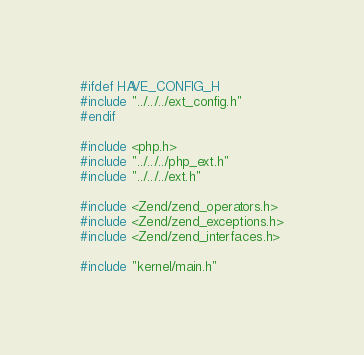Convert code to text. <code><loc_0><loc_0><loc_500><loc_500><_C_>
#ifdef HAVE_CONFIG_H
#include "../../../ext_config.h"
#endif

#include <php.h>
#include "../../../php_ext.h"
#include "../../../ext.h"

#include <Zend/zend_operators.h>
#include <Zend/zend_exceptions.h>
#include <Zend/zend_interfaces.h>

#include "kernel/main.h"</code> 